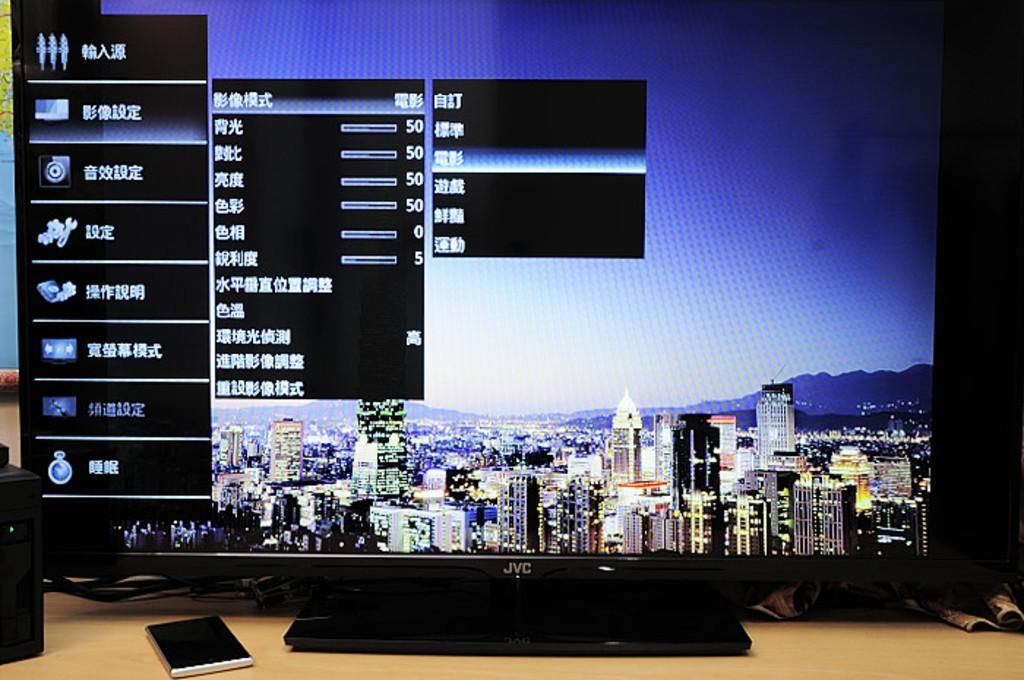Provide a one-sentence caption for the provided image. A black JVC computer monitor with a screen background of a city-scape and a settings prompt in Chinese displayed. 